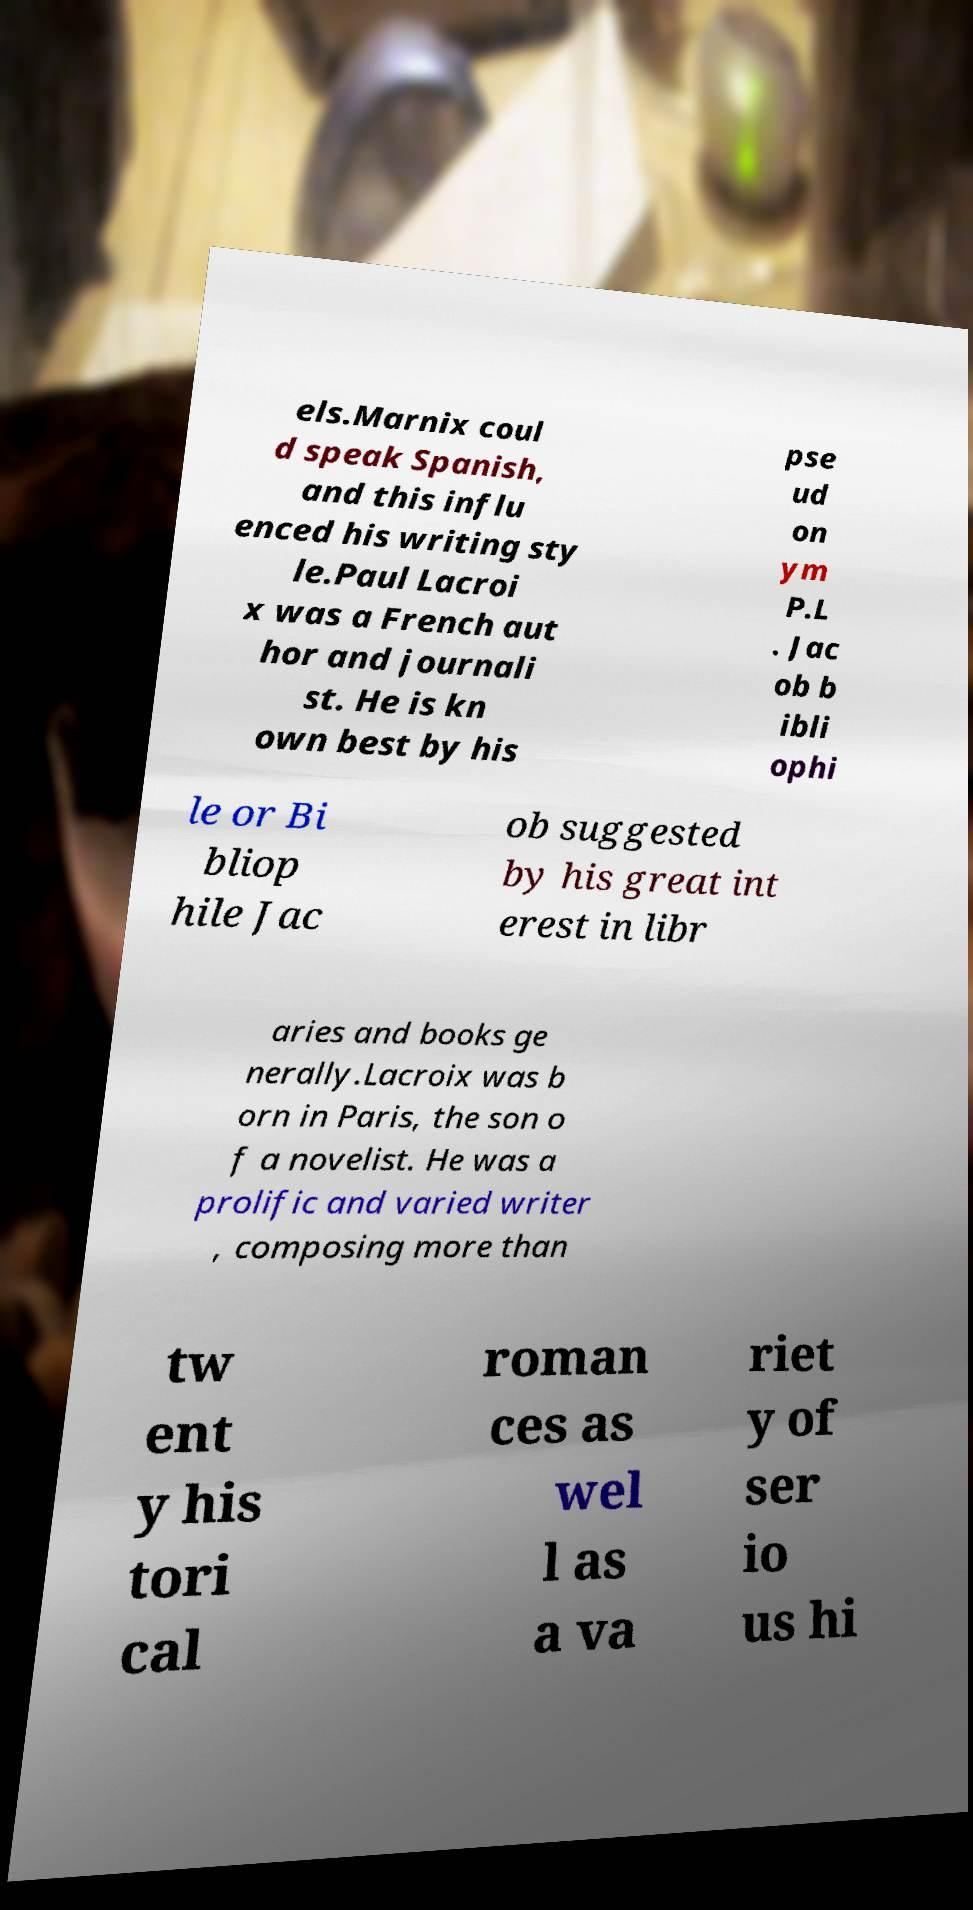Can you read and provide the text displayed in the image?This photo seems to have some interesting text. Can you extract and type it out for me? els.Marnix coul d speak Spanish, and this influ enced his writing sty le.Paul Lacroi x was a French aut hor and journali st. He is kn own best by his pse ud on ym P.L . Jac ob b ibli ophi le or Bi bliop hile Jac ob suggested by his great int erest in libr aries and books ge nerally.Lacroix was b orn in Paris, the son o f a novelist. He was a prolific and varied writer , composing more than tw ent y his tori cal roman ces as wel l as a va riet y of ser io us hi 